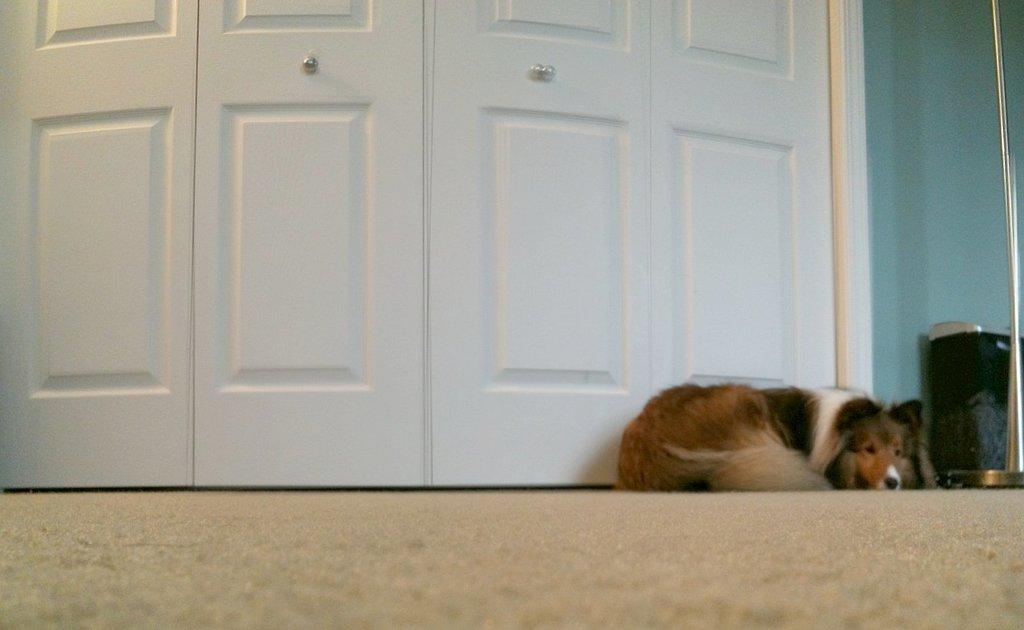What type of animal is in the image? There is a dog in the image. What color is the dog? The dog is brown in color. What is the dog doing in the image? The dog is resting on the ground. What can be seen in the background of the image? There is a door, a blue wall, and a dustbin in the background of the image. What type of apparatus is being used by the dog in the image? There is no apparatus present in the image; the dog is simply resting on the ground. 